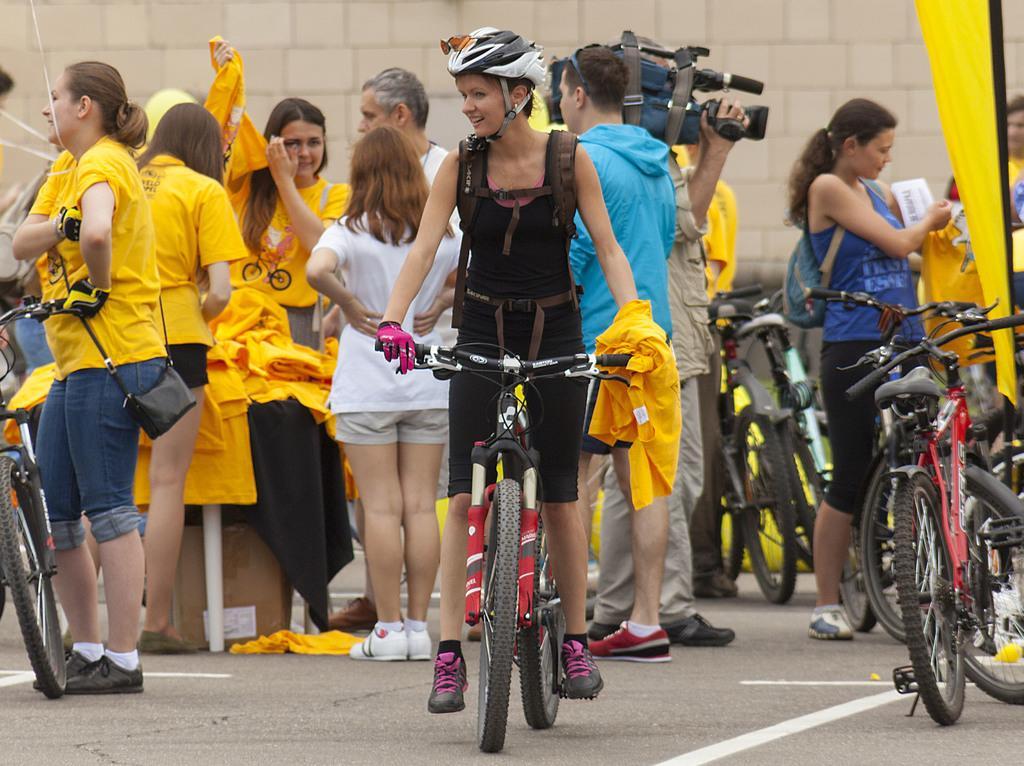Please provide a concise description of this image. A lady in black dress wearing a bag and helmet holding a cycle and having a yellow dress on her hand. Behind there are some ladies in yellow and white dress. A person is holding a camera in the back. There are some cycles in the background. There is a wall in the background. 